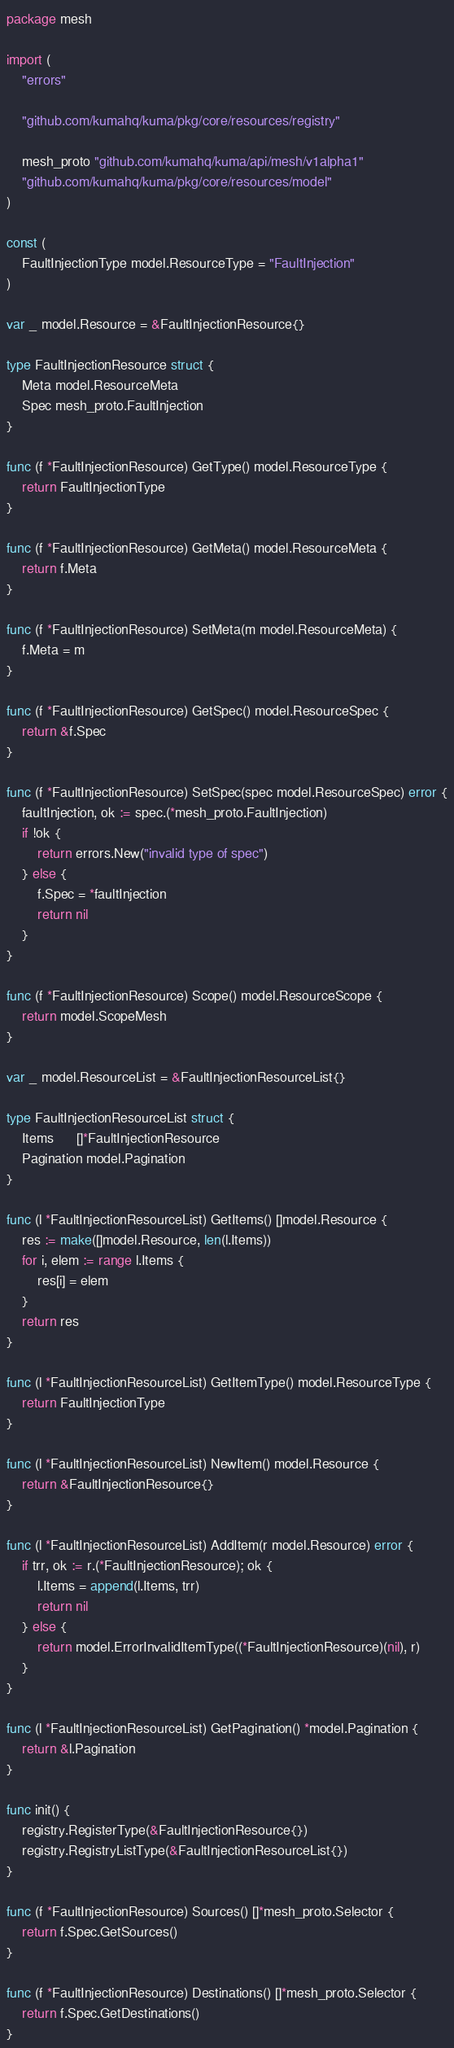Convert code to text. <code><loc_0><loc_0><loc_500><loc_500><_Go_>package mesh

import (
	"errors"

	"github.com/kumahq/kuma/pkg/core/resources/registry"

	mesh_proto "github.com/kumahq/kuma/api/mesh/v1alpha1"
	"github.com/kumahq/kuma/pkg/core/resources/model"
)

const (
	FaultInjectionType model.ResourceType = "FaultInjection"
)

var _ model.Resource = &FaultInjectionResource{}

type FaultInjectionResource struct {
	Meta model.ResourceMeta
	Spec mesh_proto.FaultInjection
}

func (f *FaultInjectionResource) GetType() model.ResourceType {
	return FaultInjectionType
}

func (f *FaultInjectionResource) GetMeta() model.ResourceMeta {
	return f.Meta
}

func (f *FaultInjectionResource) SetMeta(m model.ResourceMeta) {
	f.Meta = m
}

func (f *FaultInjectionResource) GetSpec() model.ResourceSpec {
	return &f.Spec
}

func (f *FaultInjectionResource) SetSpec(spec model.ResourceSpec) error {
	faultInjection, ok := spec.(*mesh_proto.FaultInjection)
	if !ok {
		return errors.New("invalid type of spec")
	} else {
		f.Spec = *faultInjection
		return nil
	}
}

func (f *FaultInjectionResource) Scope() model.ResourceScope {
	return model.ScopeMesh
}

var _ model.ResourceList = &FaultInjectionResourceList{}

type FaultInjectionResourceList struct {
	Items      []*FaultInjectionResource
	Pagination model.Pagination
}

func (l *FaultInjectionResourceList) GetItems() []model.Resource {
	res := make([]model.Resource, len(l.Items))
	for i, elem := range l.Items {
		res[i] = elem
	}
	return res
}

func (l *FaultInjectionResourceList) GetItemType() model.ResourceType {
	return FaultInjectionType
}

func (l *FaultInjectionResourceList) NewItem() model.Resource {
	return &FaultInjectionResource{}
}

func (l *FaultInjectionResourceList) AddItem(r model.Resource) error {
	if trr, ok := r.(*FaultInjectionResource); ok {
		l.Items = append(l.Items, trr)
		return nil
	} else {
		return model.ErrorInvalidItemType((*FaultInjectionResource)(nil), r)
	}
}

func (l *FaultInjectionResourceList) GetPagination() *model.Pagination {
	return &l.Pagination
}

func init() {
	registry.RegisterType(&FaultInjectionResource{})
	registry.RegistryListType(&FaultInjectionResourceList{})
}

func (f *FaultInjectionResource) Sources() []*mesh_proto.Selector {
	return f.Spec.GetSources()
}

func (f *FaultInjectionResource) Destinations() []*mesh_proto.Selector {
	return f.Spec.GetDestinations()
}
</code> 